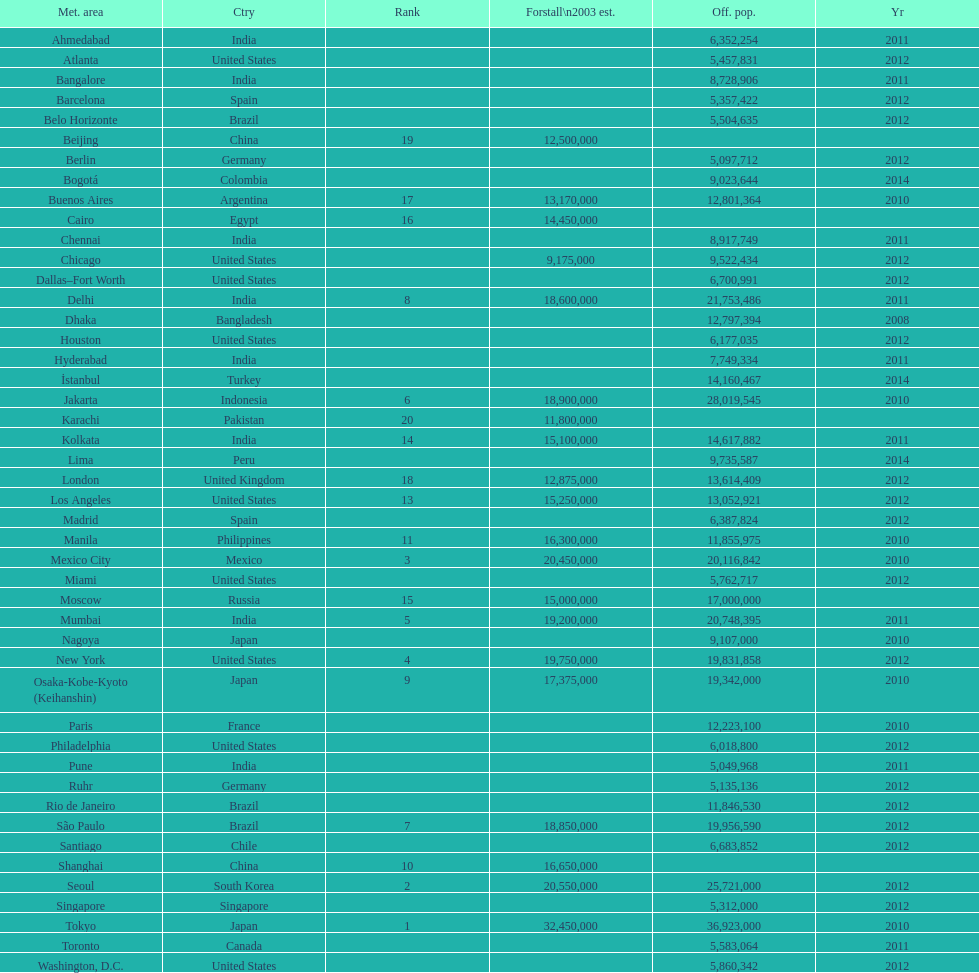How many cities are in the united states? 9. Can you give me this table as a dict? {'header': ['Met. area', 'Ctry', 'Rank', 'Forstall\\n2003 est.', 'Off. pop.', 'Yr'], 'rows': [['Ahmedabad', 'India', '', '', '6,352,254', '2011'], ['Atlanta', 'United States', '', '', '5,457,831', '2012'], ['Bangalore', 'India', '', '', '8,728,906', '2011'], ['Barcelona', 'Spain', '', '', '5,357,422', '2012'], ['Belo Horizonte', 'Brazil', '', '', '5,504,635', '2012'], ['Beijing', 'China', '19', '12,500,000', '', ''], ['Berlin', 'Germany', '', '', '5,097,712', '2012'], ['Bogotá', 'Colombia', '', '', '9,023,644', '2014'], ['Buenos Aires', 'Argentina', '17', '13,170,000', '12,801,364', '2010'], ['Cairo', 'Egypt', '16', '14,450,000', '', ''], ['Chennai', 'India', '', '', '8,917,749', '2011'], ['Chicago', 'United States', '', '9,175,000', '9,522,434', '2012'], ['Dallas–Fort Worth', 'United States', '', '', '6,700,991', '2012'], ['Delhi', 'India', '8', '18,600,000', '21,753,486', '2011'], ['Dhaka', 'Bangladesh', '', '', '12,797,394', '2008'], ['Houston', 'United States', '', '', '6,177,035', '2012'], ['Hyderabad', 'India', '', '', '7,749,334', '2011'], ['İstanbul', 'Turkey', '', '', '14,160,467', '2014'], ['Jakarta', 'Indonesia', '6', '18,900,000', '28,019,545', '2010'], ['Karachi', 'Pakistan', '20', '11,800,000', '', ''], ['Kolkata', 'India', '14', '15,100,000', '14,617,882', '2011'], ['Lima', 'Peru', '', '', '9,735,587', '2014'], ['London', 'United Kingdom', '18', '12,875,000', '13,614,409', '2012'], ['Los Angeles', 'United States', '13', '15,250,000', '13,052,921', '2012'], ['Madrid', 'Spain', '', '', '6,387,824', '2012'], ['Manila', 'Philippines', '11', '16,300,000', '11,855,975', '2010'], ['Mexico City', 'Mexico', '3', '20,450,000', '20,116,842', '2010'], ['Miami', 'United States', '', '', '5,762,717', '2012'], ['Moscow', 'Russia', '15', '15,000,000', '17,000,000', ''], ['Mumbai', 'India', '5', '19,200,000', '20,748,395', '2011'], ['Nagoya', 'Japan', '', '', '9,107,000', '2010'], ['New York', 'United States', '4', '19,750,000', '19,831,858', '2012'], ['Osaka-Kobe-Kyoto (Keihanshin)', 'Japan', '9', '17,375,000', '19,342,000', '2010'], ['Paris', 'France', '', '', '12,223,100', '2010'], ['Philadelphia', 'United States', '', '', '6,018,800', '2012'], ['Pune', 'India', '', '', '5,049,968', '2011'], ['Ruhr', 'Germany', '', '', '5,135,136', '2012'], ['Rio de Janeiro', 'Brazil', '', '', '11,846,530', '2012'], ['São Paulo', 'Brazil', '7', '18,850,000', '19,956,590', '2012'], ['Santiago', 'Chile', '', '', '6,683,852', '2012'], ['Shanghai', 'China', '10', '16,650,000', '', ''], ['Seoul', 'South Korea', '2', '20,550,000', '25,721,000', '2012'], ['Singapore', 'Singapore', '', '', '5,312,000', '2012'], ['Tokyo', 'Japan', '1', '32,450,000', '36,923,000', '2010'], ['Toronto', 'Canada', '', '', '5,583,064', '2011'], ['Washington, D.C.', 'United States', '', '', '5,860,342', '2012']]} 